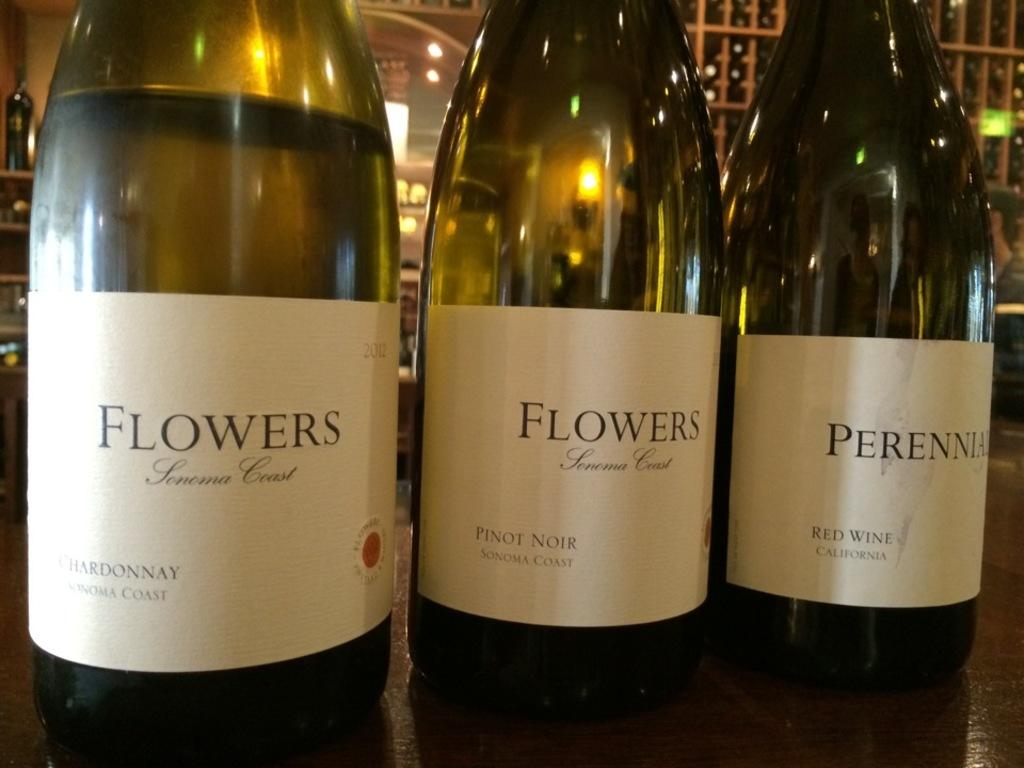Provide a one-sentence caption for the provided image. Three bottles sit on a table with two bottles with labels that read, "Flowers.". 